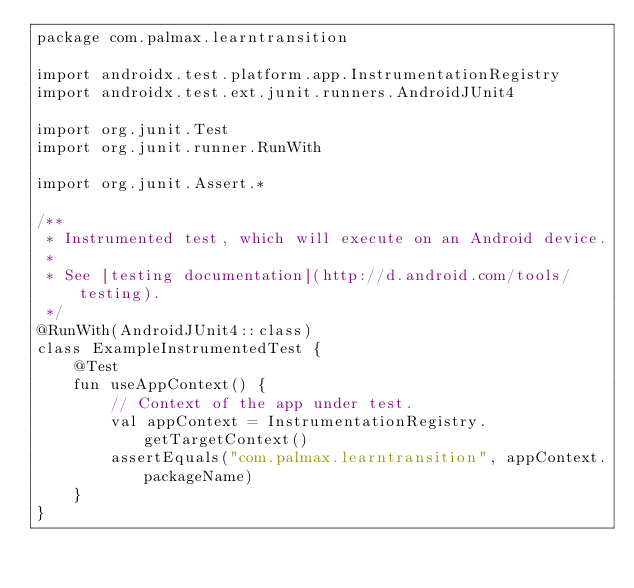Convert code to text. <code><loc_0><loc_0><loc_500><loc_500><_Kotlin_>package com.palmax.learntransition

import androidx.test.platform.app.InstrumentationRegistry
import androidx.test.ext.junit.runners.AndroidJUnit4

import org.junit.Test
import org.junit.runner.RunWith

import org.junit.Assert.*

/**
 * Instrumented test, which will execute on an Android device.
 *
 * See [testing documentation](http://d.android.com/tools/testing).
 */
@RunWith(AndroidJUnit4::class)
class ExampleInstrumentedTest {
    @Test
    fun useAppContext() {
        // Context of the app under test.
        val appContext = InstrumentationRegistry.getTargetContext()
        assertEquals("com.palmax.learntransition", appContext.packageName)
    }
}
</code> 